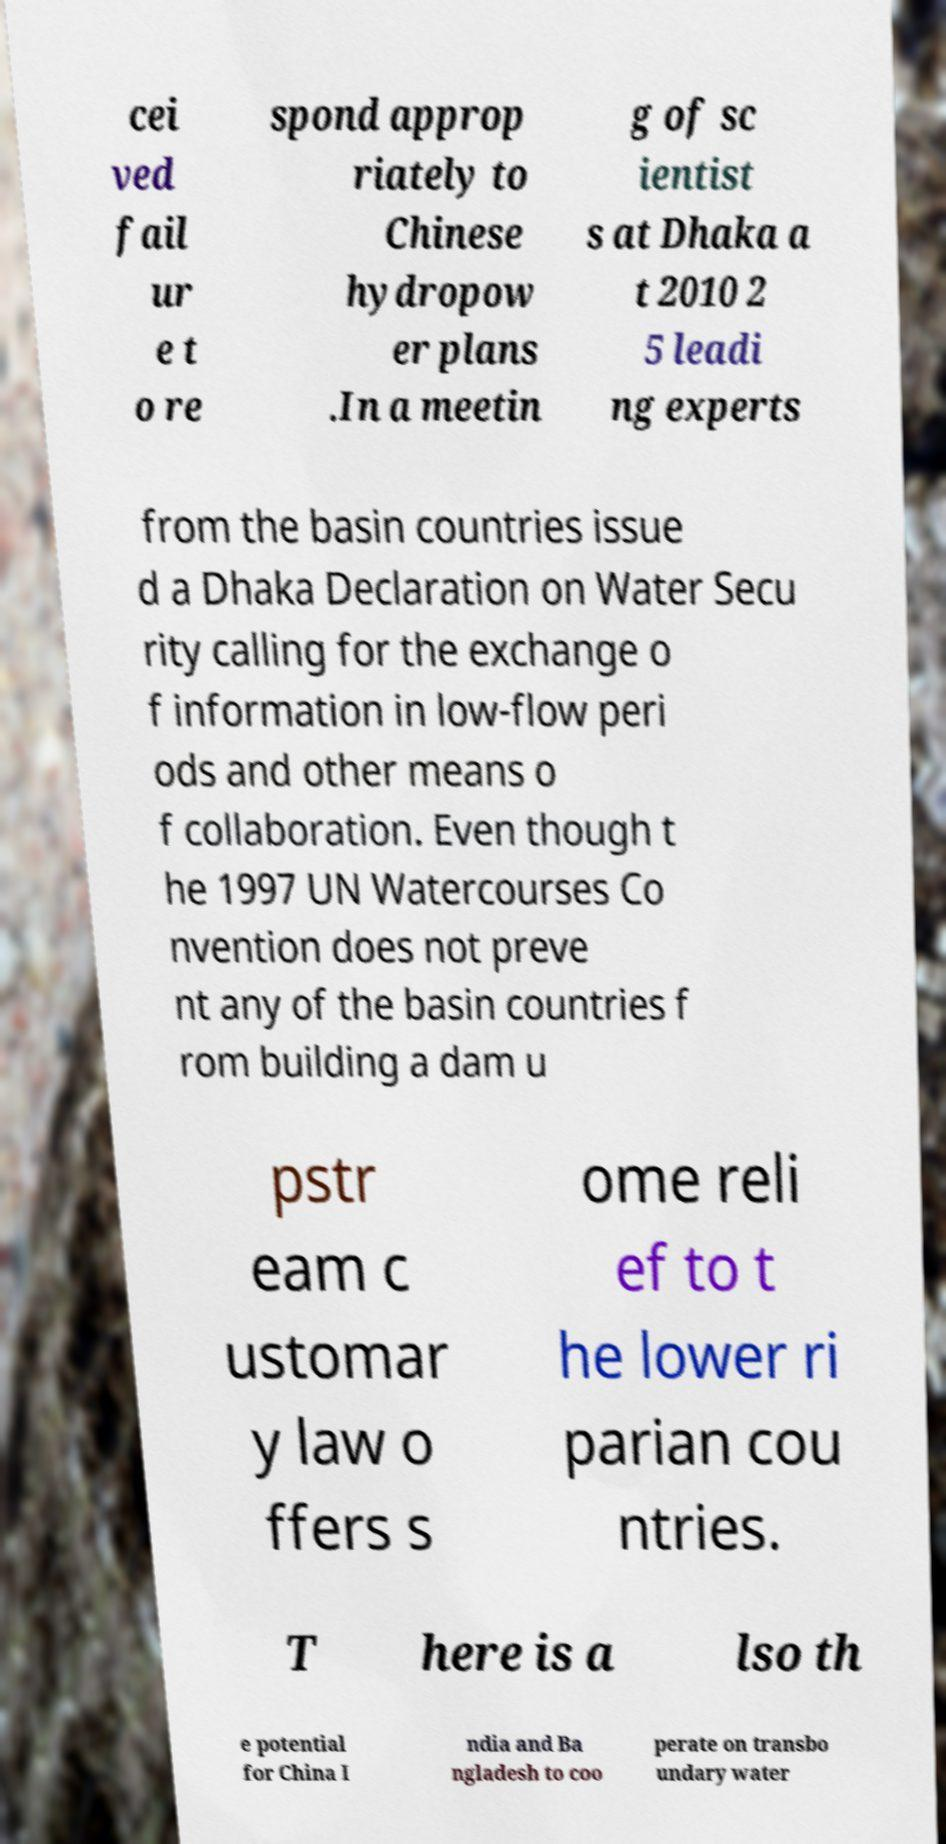Can you accurately transcribe the text from the provided image for me? cei ved fail ur e t o re spond approp riately to Chinese hydropow er plans .In a meetin g of sc ientist s at Dhaka a t 2010 2 5 leadi ng experts from the basin countries issue d a Dhaka Declaration on Water Secu rity calling for the exchange o f information in low-flow peri ods and other means o f collaboration. Even though t he 1997 UN Watercourses Co nvention does not preve nt any of the basin countries f rom building a dam u pstr eam c ustomar y law o ffers s ome reli ef to t he lower ri parian cou ntries. T here is a lso th e potential for China I ndia and Ba ngladesh to coo perate on transbo undary water 